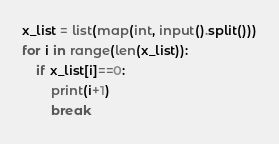<code> <loc_0><loc_0><loc_500><loc_500><_Python_>x_list = list(map(int, input().split()))
for i in range(len(x_list)):
    if x_list[i]==0:
        print(i+1)
        break</code> 